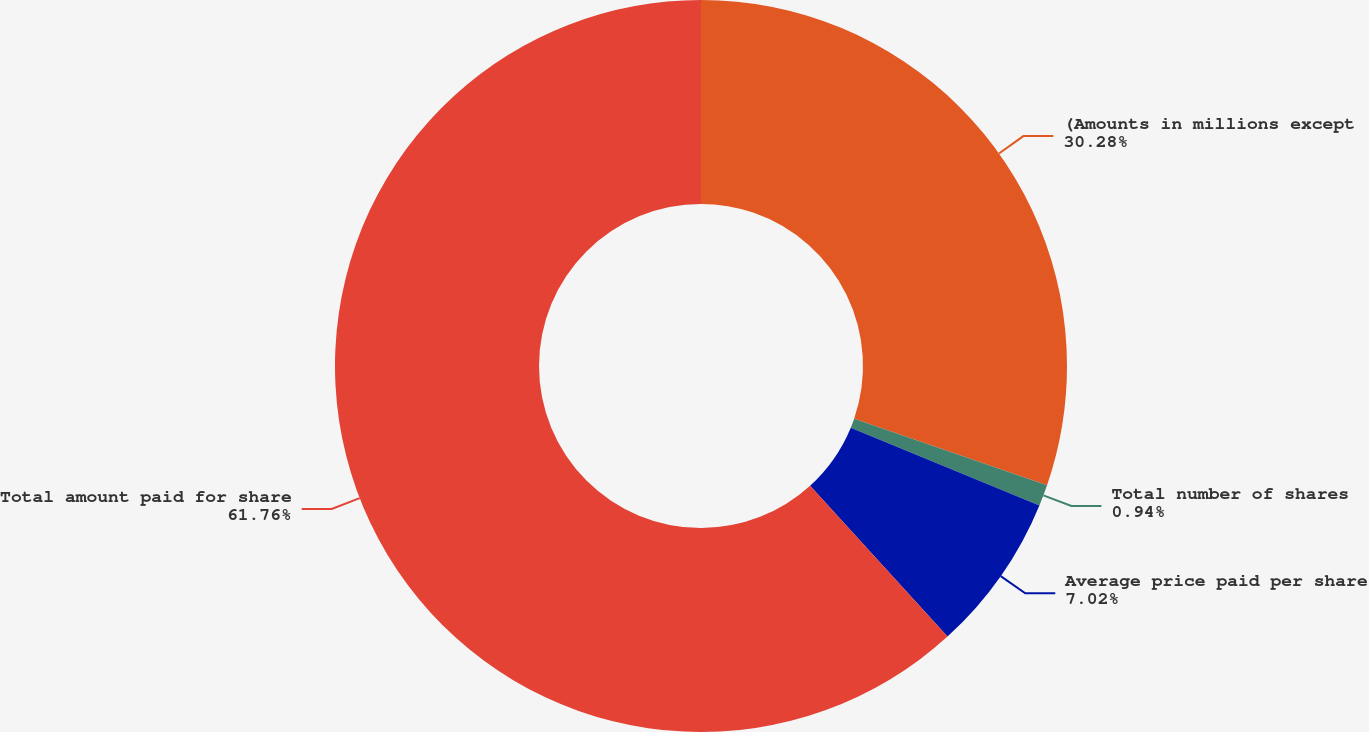Convert chart. <chart><loc_0><loc_0><loc_500><loc_500><pie_chart><fcel>(Amounts in millions except<fcel>Total number of shares<fcel>Average price paid per share<fcel>Total amount paid for share<nl><fcel>30.28%<fcel>0.94%<fcel>7.02%<fcel>61.76%<nl></chart> 